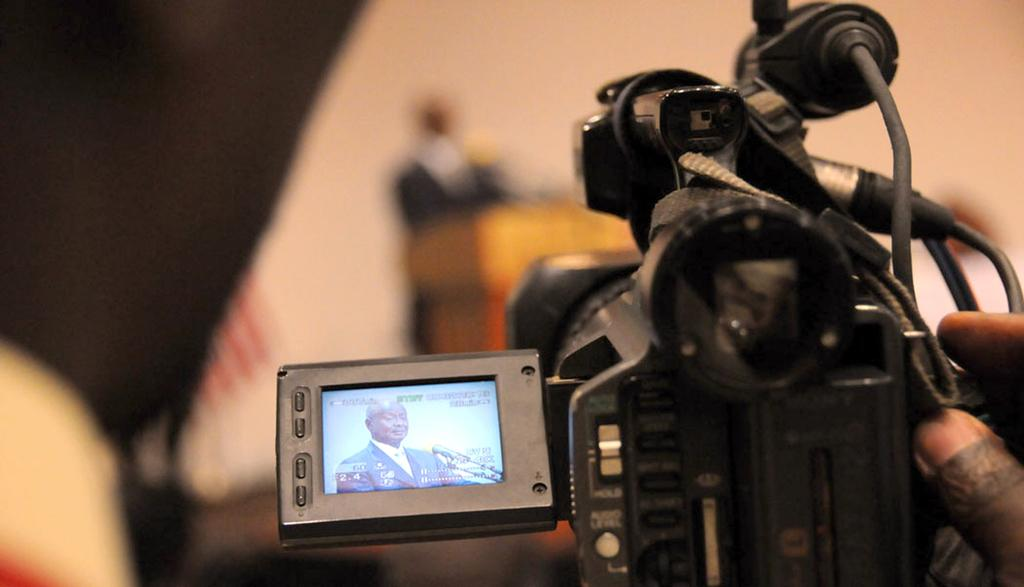What is the main object in the image? There is a video camera in the image. Can you describe the background of the image? The background of the image is blurred. How many ladybugs can be seen crawling on the video camera in the image? There are no ladybugs present in the image. What type of things are being captured by the video camera in the image? The image does not show what the video camera is capturing, so we cannot determine the type of things being recorded. 